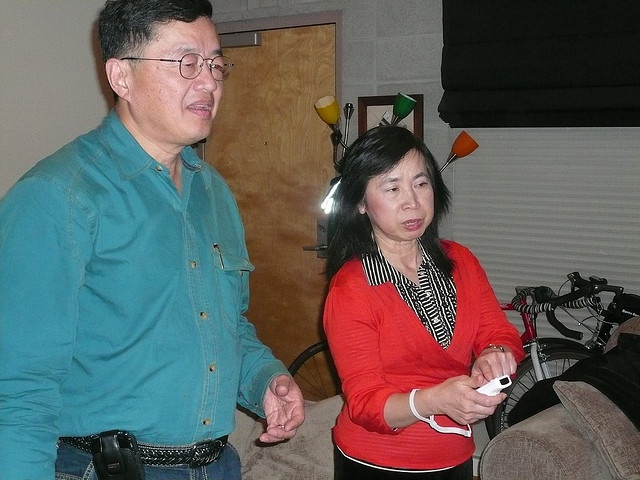Describe the objects in this image and their specific colors. I can see people in gray, teal, lightpink, and black tones, people in gray, brown, black, and lightpink tones, couch in gray and black tones, bicycle in gray, black, darkgray, and maroon tones, and bicycle in gray, black, and maroon tones in this image. 